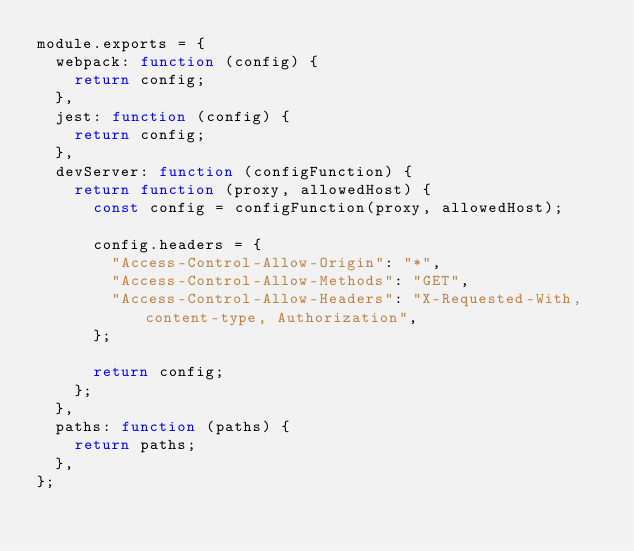<code> <loc_0><loc_0><loc_500><loc_500><_JavaScript_>module.exports = {
  webpack: function (config) {
    return config;
  },
  jest: function (config) {
    return config;
  },
  devServer: function (configFunction) {
    return function (proxy, allowedHost) {
      const config = configFunction(proxy, allowedHost);

      config.headers = {
        "Access-Control-Allow-Origin": "*",
        "Access-Control-Allow-Methods": "GET",
        "Access-Control-Allow-Headers": "X-Requested-With, content-type, Authorization",
      };

      return config;
    };
  },
  paths: function (paths) {
    return paths;
  },
};
</code> 